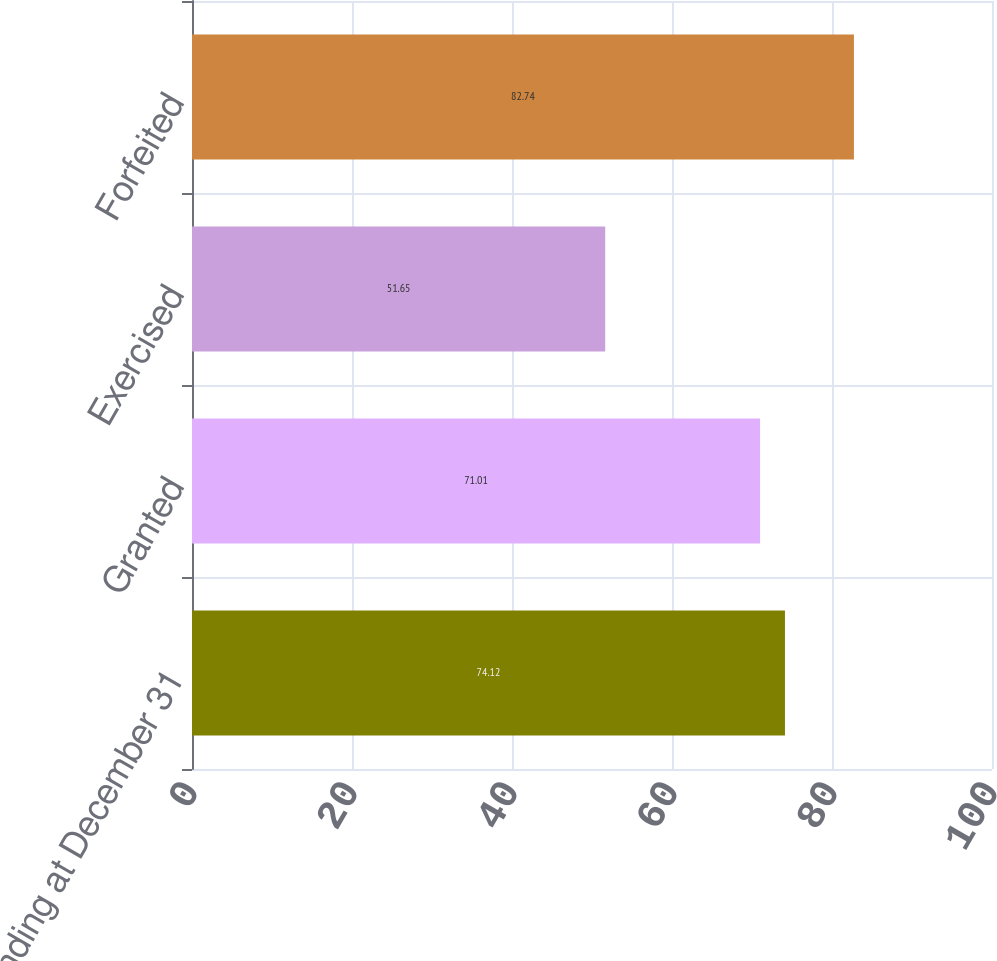Convert chart. <chart><loc_0><loc_0><loc_500><loc_500><bar_chart><fcel>Outstanding at December 31<fcel>Granted<fcel>Exercised<fcel>Forfeited<nl><fcel>74.12<fcel>71.01<fcel>51.65<fcel>82.74<nl></chart> 